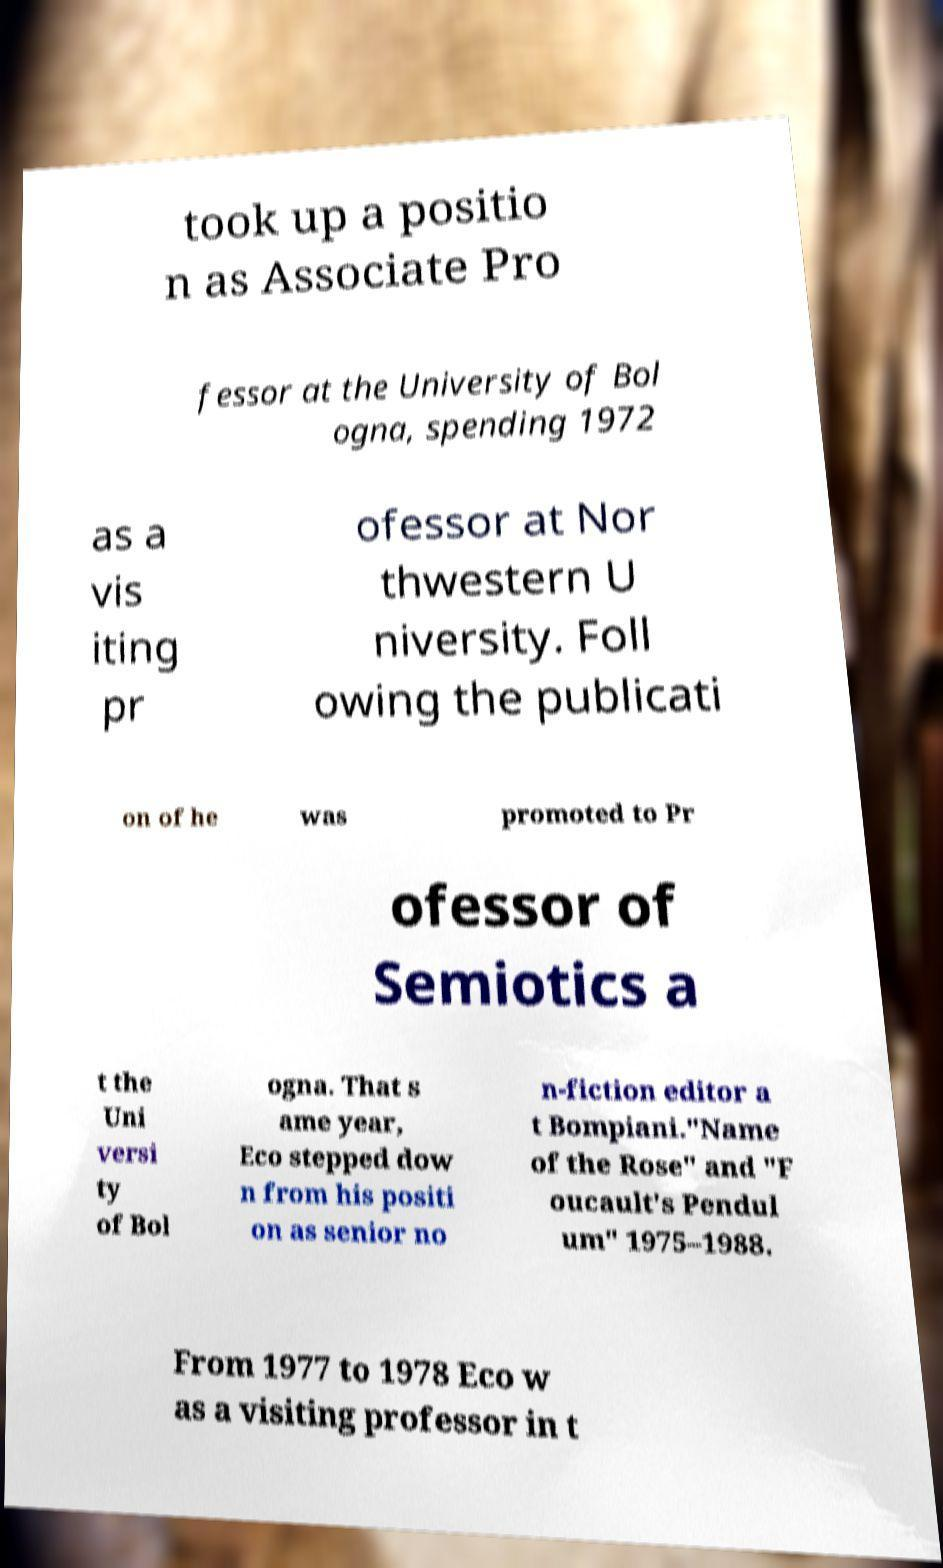Please identify and transcribe the text found in this image. took up a positio n as Associate Pro fessor at the University of Bol ogna, spending 1972 as a vis iting pr ofessor at Nor thwestern U niversity. Foll owing the publicati on of he was promoted to Pr ofessor of Semiotics a t the Uni versi ty of Bol ogna. That s ame year, Eco stepped dow n from his positi on as senior no n-fiction editor a t Bompiani."Name of the Rose" and "F oucault's Pendul um" 1975–1988. From 1977 to 1978 Eco w as a visiting professor in t 